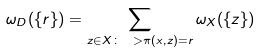<formula> <loc_0><loc_0><loc_500><loc_500>\omega _ { D } ( \{ r \} ) = \sum _ { z \in X \colon \ > \pi ( x , z ) = r } \omega _ { X } ( \{ z \} )</formula> 